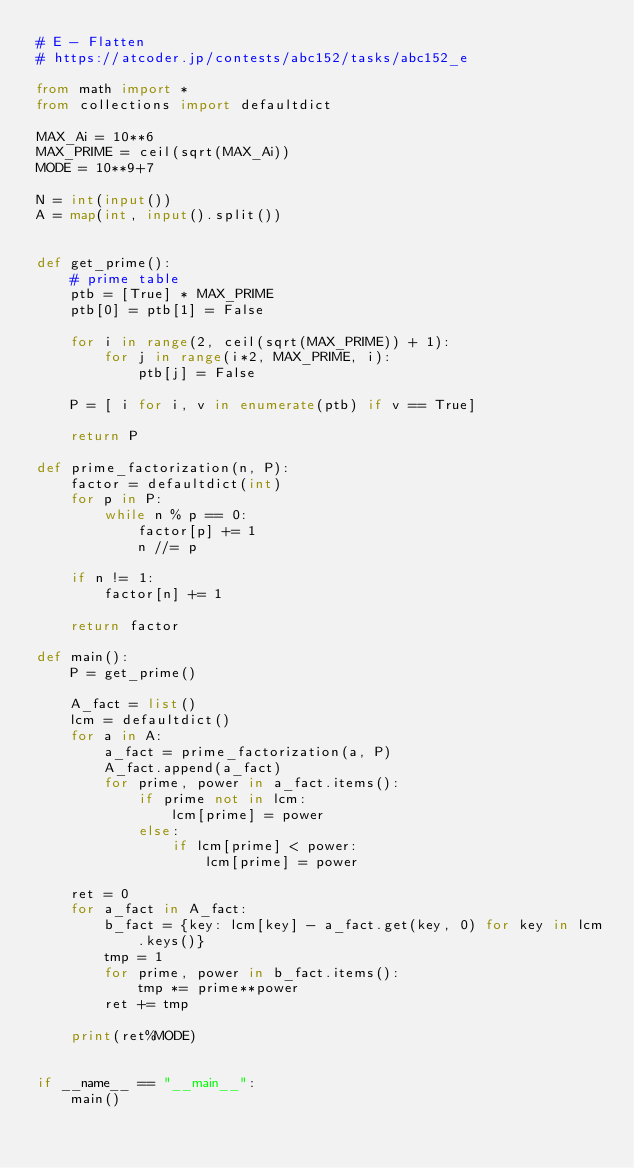<code> <loc_0><loc_0><loc_500><loc_500><_Python_># E - Flatten
# https://atcoder.jp/contests/abc152/tasks/abc152_e

from math import *
from collections import defaultdict

MAX_Ai = 10**6
MAX_PRIME = ceil(sqrt(MAX_Ai))
MODE = 10**9+7

N = int(input())
A = map(int, input().split())


def get_prime():
    # prime table
    ptb = [True] * MAX_PRIME
    ptb[0] = ptb[1] = False

    for i in range(2, ceil(sqrt(MAX_PRIME)) + 1):
        for j in range(i*2, MAX_PRIME, i):
            ptb[j] = False

    P = [ i for i, v in enumerate(ptb) if v == True]

    return P

def prime_factorization(n, P):
    factor = defaultdict(int)
    for p in P:
        while n % p == 0:
            factor[p] += 1
            n //= p

    if n != 1:
        factor[n] += 1

    return factor

def main():
    P = get_prime()    

    A_fact = list()
    lcm = defaultdict()
    for a in A:
        a_fact = prime_factorization(a, P)
        A_fact.append(a_fact)
        for prime, power in a_fact.items():
            if prime not in lcm:
                lcm[prime] = power
            else:
                if lcm[prime] < power:
                    lcm[prime] = power

    ret = 0
    for a_fact in A_fact:
        b_fact = {key: lcm[key] - a_fact.get(key, 0) for key in lcm.keys()}
        tmp = 1
        for prime, power in b_fact.items():
            tmp *= prime**power
        ret += tmp

    print(ret%MODE)


if __name__ == "__main__":
    main()
</code> 